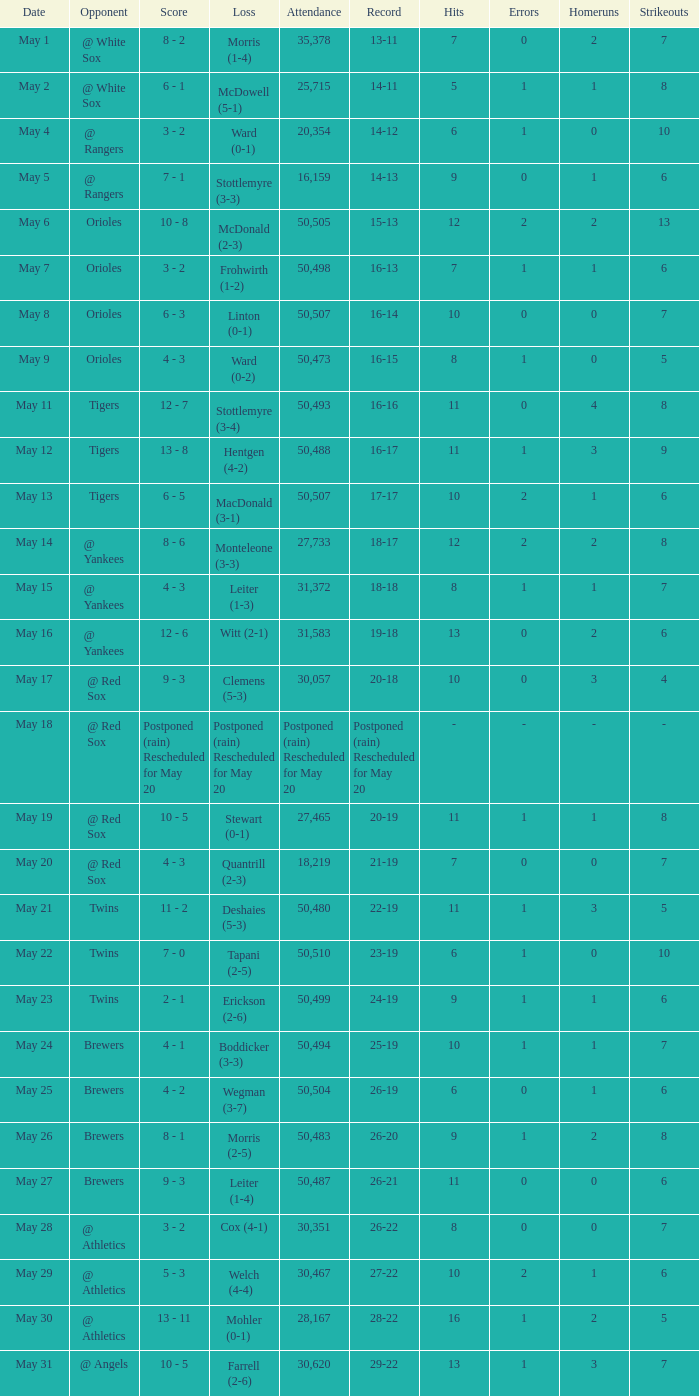Give me the full table as a dictionary. {'header': ['Date', 'Opponent', 'Score', 'Loss', 'Attendance', 'Record', 'Hits', 'Errors', 'Homeruns', 'Strikeouts'], 'rows': [['May 1', '@ White Sox', '8 - 2', 'Morris (1-4)', '35,378', '13-11', '7', '0', '2', '7'], ['May 2', '@ White Sox', '6 - 1', 'McDowell (5-1)', '25,715', '14-11', '5', '1', '1', '8'], ['May 4', '@ Rangers', '3 - 2', 'Ward (0-1)', '20,354', '14-12', '6', '1', '0', '10'], ['May 5', '@ Rangers', '7 - 1', 'Stottlemyre (3-3)', '16,159', '14-13', '9', '0', '1', '6'], ['May 6', 'Orioles', '10 - 8', 'McDonald (2-3)', '50,505', '15-13', '12', '2', '2', '13'], ['May 7', 'Orioles', '3 - 2', 'Frohwirth (1-2)', '50,498', '16-13', '7', '1', '1', '6'], ['May 8', 'Orioles', '6 - 3', 'Linton (0-1)', '50,507', '16-14', '10', '0', '0', '7'], ['May 9', 'Orioles', '4 - 3', 'Ward (0-2)', '50,473', '16-15', '8', '1', '0', '5'], ['May 11', 'Tigers', '12 - 7', 'Stottlemyre (3-4)', '50,493', '16-16', '11', '0', '4', '8'], ['May 12', 'Tigers', '13 - 8', 'Hentgen (4-2)', '50,488', '16-17', '11', '1', '3', '9'], ['May 13', 'Tigers', '6 - 5', 'MacDonald (3-1)', '50,507', '17-17', '10', '2', '1', '6'], ['May 14', '@ Yankees', '8 - 6', 'Monteleone (3-3)', '27,733', '18-17', '12', '2', '2', '8'], ['May 15', '@ Yankees', '4 - 3', 'Leiter (1-3)', '31,372', '18-18', '8', '1', '1', '7'], ['May 16', '@ Yankees', '12 - 6', 'Witt (2-1)', '31,583', '19-18', '13', '0', '2', '6'], ['May 17', '@ Red Sox', '9 - 3', 'Clemens (5-3)', '30,057', '20-18', '10', '0', '3', '4'], ['May 18', '@ Red Sox', 'Postponed (rain) Rescheduled for May 20', 'Postponed (rain) Rescheduled for May 20', 'Postponed (rain) Rescheduled for May 20', 'Postponed (rain) Rescheduled for May 20', '-', '-', '-', '-'], ['May 19', '@ Red Sox', '10 - 5', 'Stewart (0-1)', '27,465', '20-19', '11', '1', '1', '8'], ['May 20', '@ Red Sox', '4 - 3', 'Quantrill (2-3)', '18,219', '21-19', '7', '0', '0', '7'], ['May 21', 'Twins', '11 - 2', 'Deshaies (5-3)', '50,480', '22-19', '11', '1', '3', '5'], ['May 22', 'Twins', '7 - 0', 'Tapani (2-5)', '50,510', '23-19', '6', '1', '0', '10'], ['May 23', 'Twins', '2 - 1', 'Erickson (2-6)', '50,499', '24-19', '9', '1', '1', '6'], ['May 24', 'Brewers', '4 - 1', 'Boddicker (3-3)', '50,494', '25-19', '10', '1', '1', '7'], ['May 25', 'Brewers', '4 - 2', 'Wegman (3-7)', '50,504', '26-19', '6', '0', '1', '6'], ['May 26', 'Brewers', '8 - 1', 'Morris (2-5)', '50,483', '26-20', '9', '1', '2', '8'], ['May 27', 'Brewers', '9 - 3', 'Leiter (1-4)', '50,487', '26-21', '11', '0', '0', '6'], ['May 28', '@ Athletics', '3 - 2', 'Cox (4-1)', '30,351', '26-22', '8', '0', '0', '7'], ['May 29', '@ Athletics', '5 - 3', 'Welch (4-4)', '30,467', '27-22', '10', '2', '1', '6'], ['May 30', '@ Athletics', '13 - 11', 'Mohler (0-1)', '28,167', '28-22', '16', '1', '2', '5'], ['May 31', '@ Angels', '10 - 5', 'Farrell (2-6)', '30,620', '29-22', '13', '1', '3', '7']]} On what date was their record 26-19? May 25. 